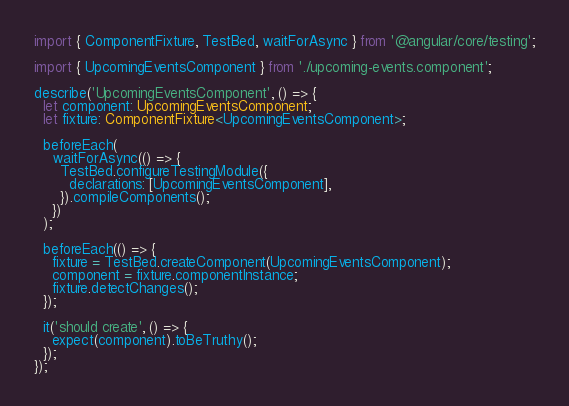Convert code to text. <code><loc_0><loc_0><loc_500><loc_500><_TypeScript_>import { ComponentFixture, TestBed, waitForAsync } from '@angular/core/testing';

import { UpcomingEventsComponent } from './upcoming-events.component';

describe('UpcomingEventsComponent', () => {
  let component: UpcomingEventsComponent;
  let fixture: ComponentFixture<UpcomingEventsComponent>;

  beforeEach(
    waitForAsync(() => {
      TestBed.configureTestingModule({
        declarations: [UpcomingEventsComponent],
      }).compileComponents();
    })
  );

  beforeEach(() => {
    fixture = TestBed.createComponent(UpcomingEventsComponent);
    component = fixture.componentInstance;
    fixture.detectChanges();
  });

  it('should create', () => {
    expect(component).toBeTruthy();
  });
});
</code> 